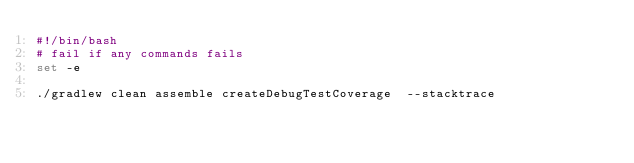Convert code to text. <code><loc_0><loc_0><loc_500><loc_500><_Bash_>#!/bin/bash
# fail if any commands fails
set -e

./gradlew clean assemble createDebugTestCoverage  --stacktrace
</code> 